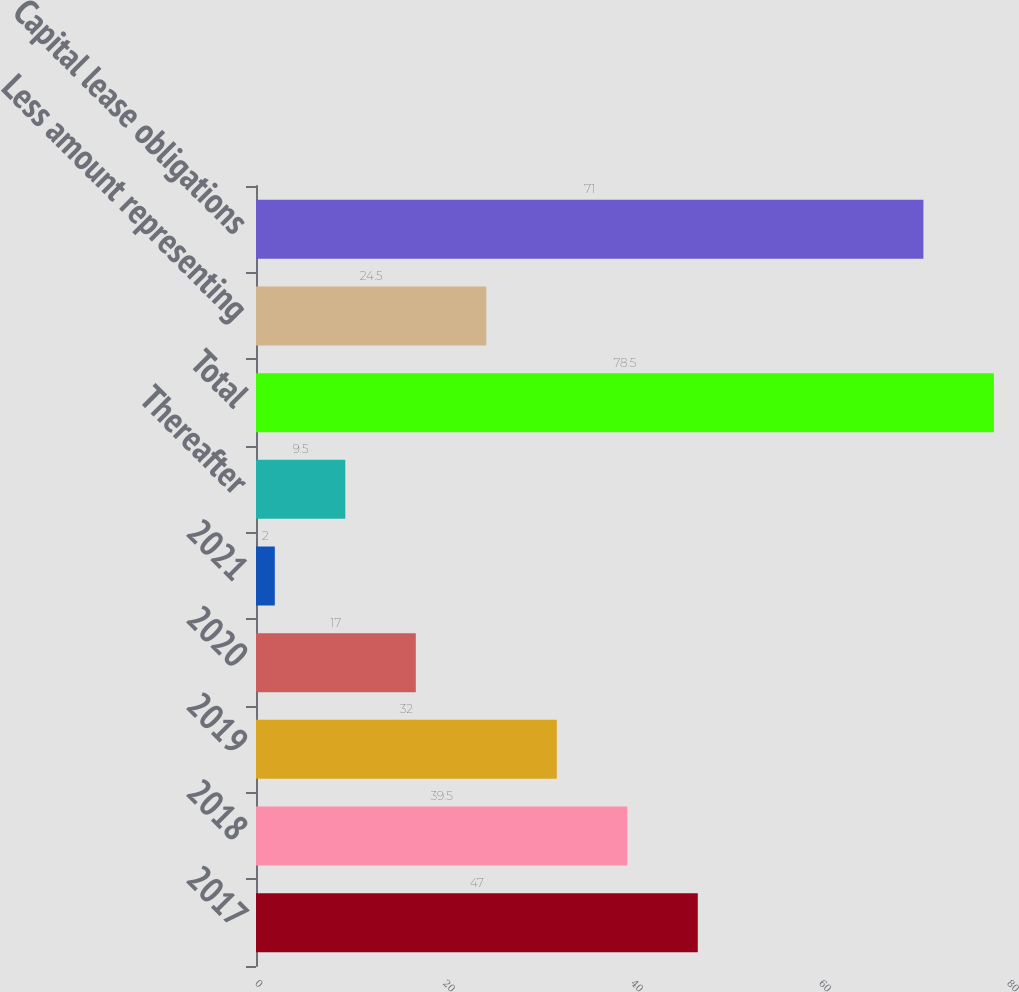Convert chart to OTSL. <chart><loc_0><loc_0><loc_500><loc_500><bar_chart><fcel>2017<fcel>2018<fcel>2019<fcel>2020<fcel>2021<fcel>Thereafter<fcel>Total<fcel>Less amount representing<fcel>Capital lease obligations<nl><fcel>47<fcel>39.5<fcel>32<fcel>17<fcel>2<fcel>9.5<fcel>78.5<fcel>24.5<fcel>71<nl></chart> 